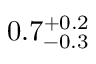Convert formula to latex. <formula><loc_0><loc_0><loc_500><loc_500>0 . 7 _ { - 0 . 3 } ^ { + 0 . 2 }</formula> 